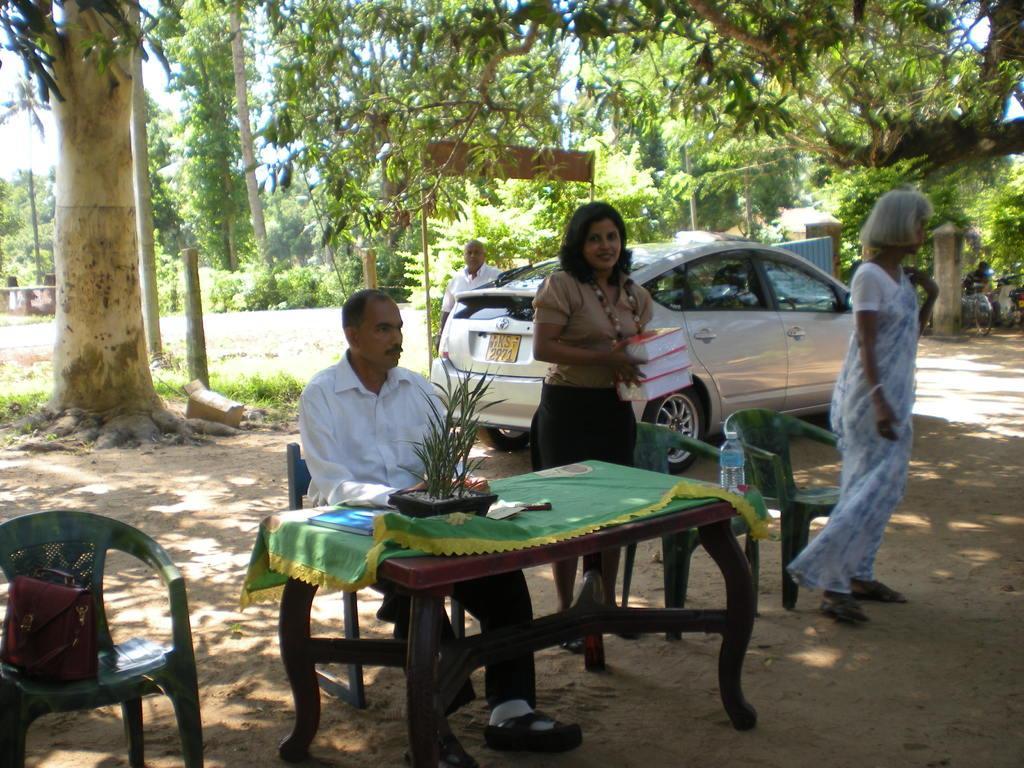In one or two sentences, can you explain what this image depicts? there are people. in the front there is a table on which there is a plant. behind them there is a car. behind them there are trees. 